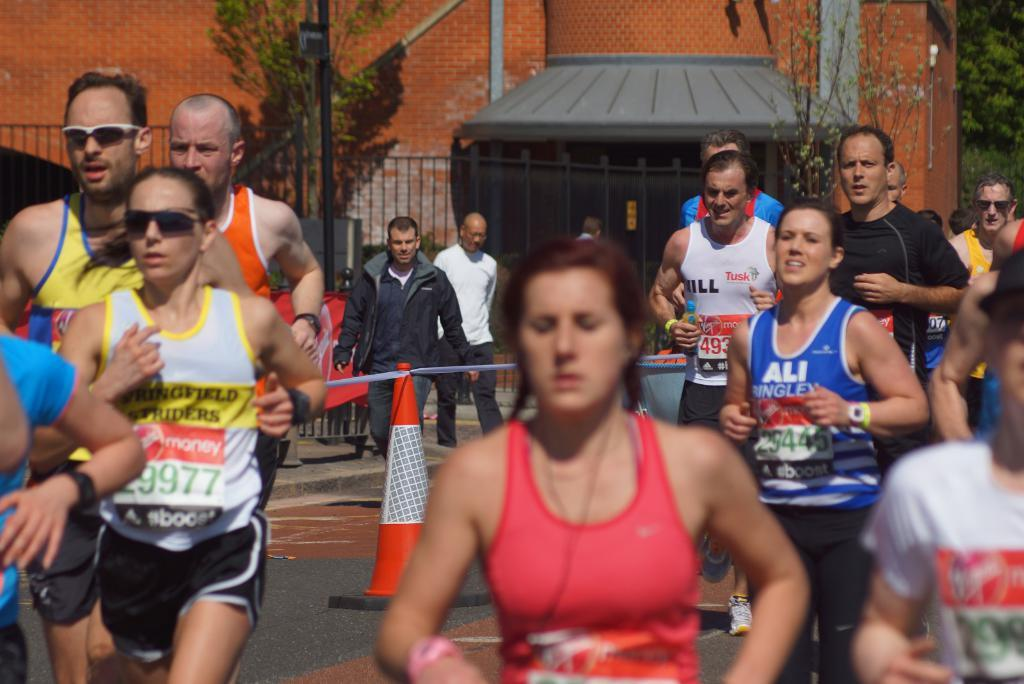<image>
Provide a brief description of the given image. A woman in a crowd of runners wears a shirt with Springfield on it. 